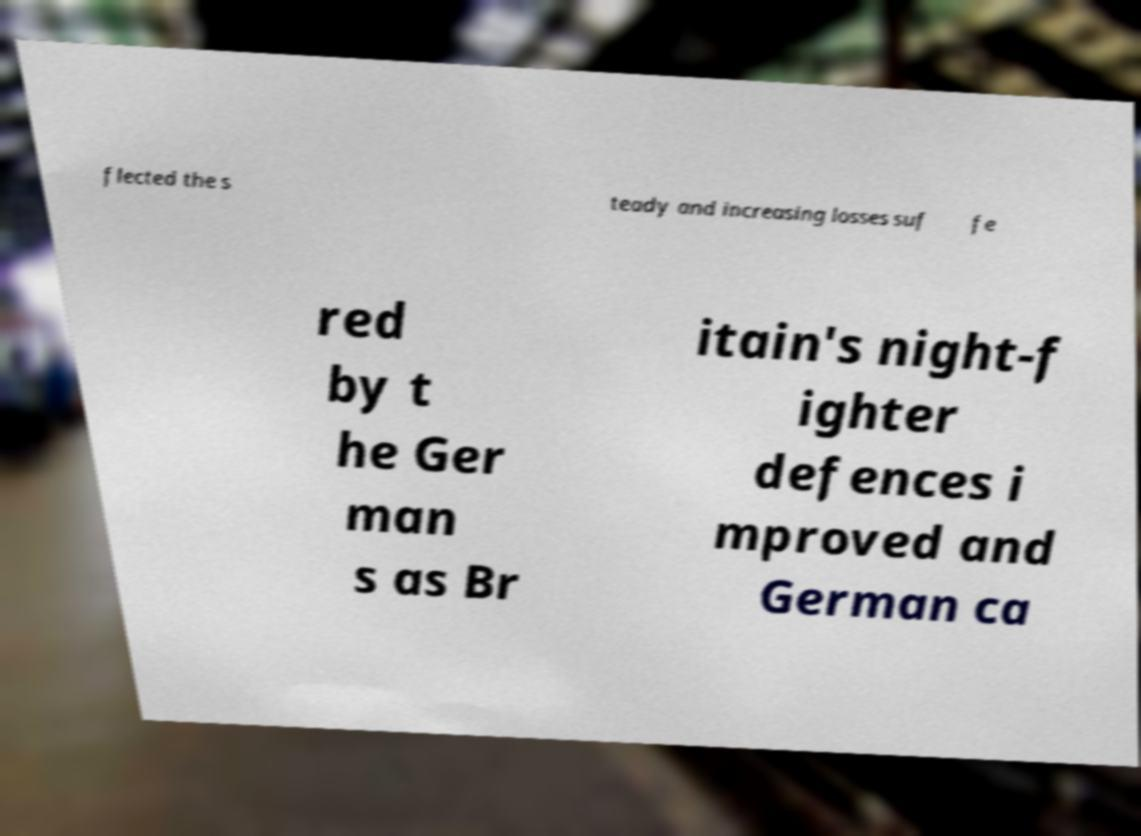For documentation purposes, I need the text within this image transcribed. Could you provide that? flected the s teady and increasing losses suf fe red by t he Ger man s as Br itain's night-f ighter defences i mproved and German ca 